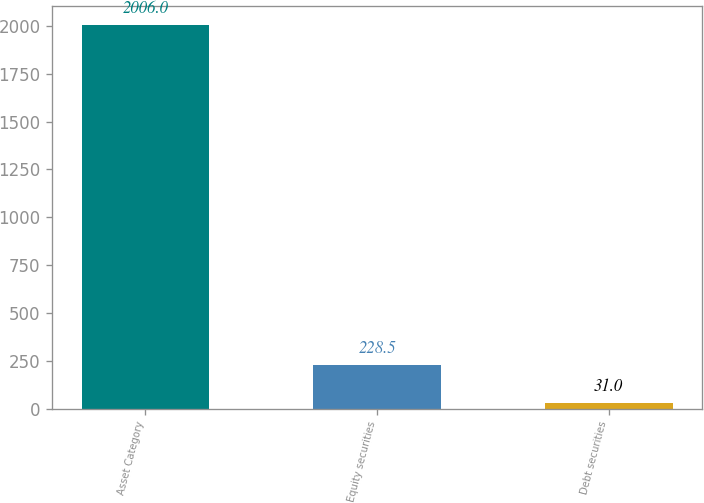Convert chart to OTSL. <chart><loc_0><loc_0><loc_500><loc_500><bar_chart><fcel>Asset Category<fcel>Equity securities<fcel>Debt securities<nl><fcel>2006<fcel>228.5<fcel>31<nl></chart> 